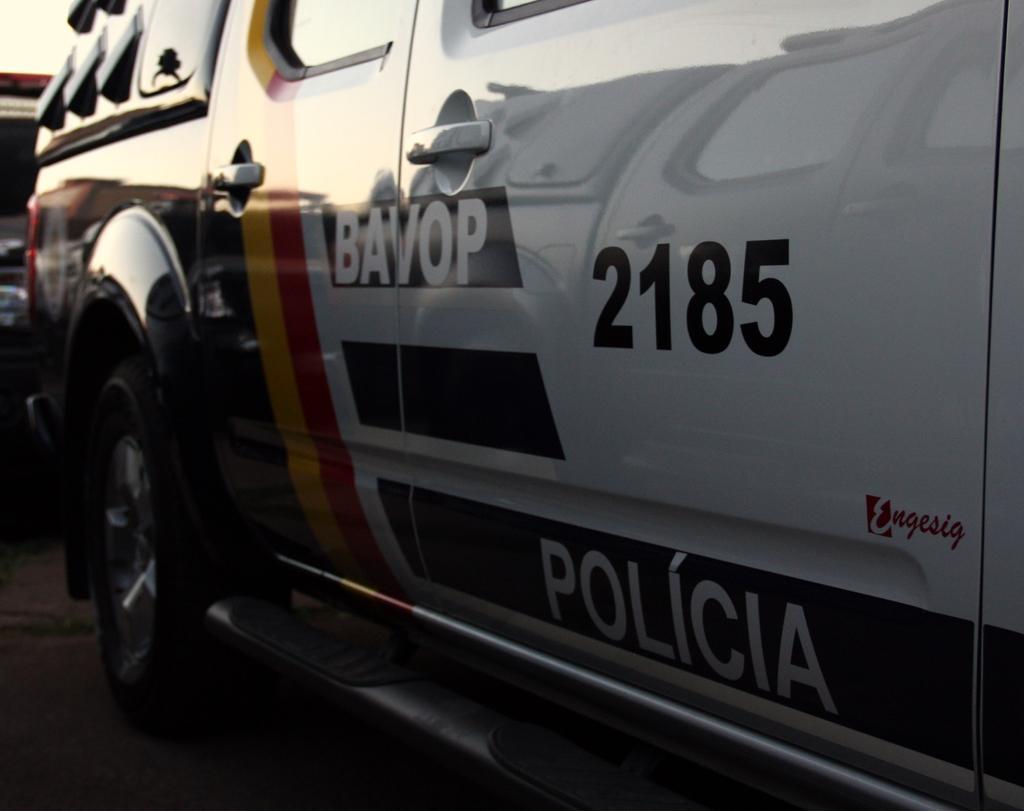Please provide a concise description of this image. In this picture we can see vehicles on the path. We can see the text, numbers, glass objects and a few things on a vehicle. 